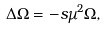<formula> <loc_0><loc_0><loc_500><loc_500>\Delta \Omega = - s \mu ^ { 2 } \Omega ,</formula> 